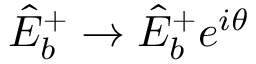Convert formula to latex. <formula><loc_0><loc_0><loc_500><loc_500>\hat { E } _ { b } ^ { + } \rightarrow \hat { E } _ { b } ^ { + } e ^ { i \theta }</formula> 